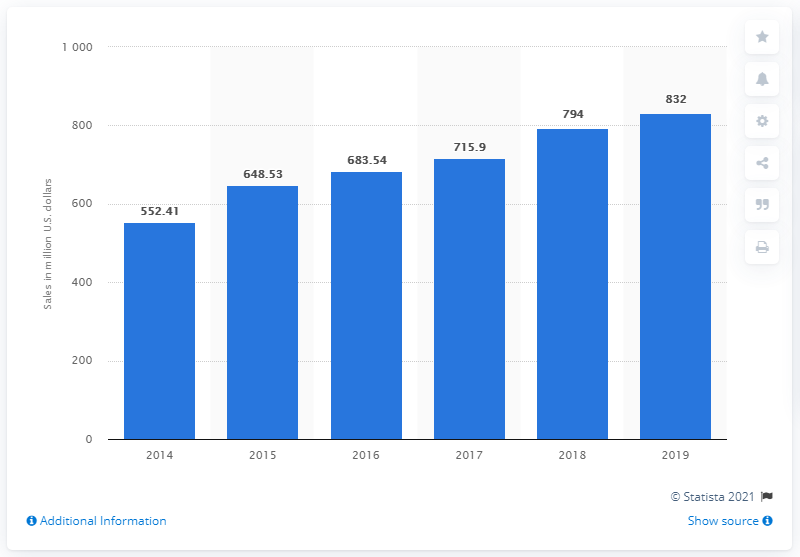Indicate a few pertinent items in this graphic. In the year 2019, Firehouse Subs generated a total sales revenue of 832 dollars. 